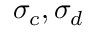<formula> <loc_0><loc_0><loc_500><loc_500>\sigma _ { c } , \sigma _ { d }</formula> 